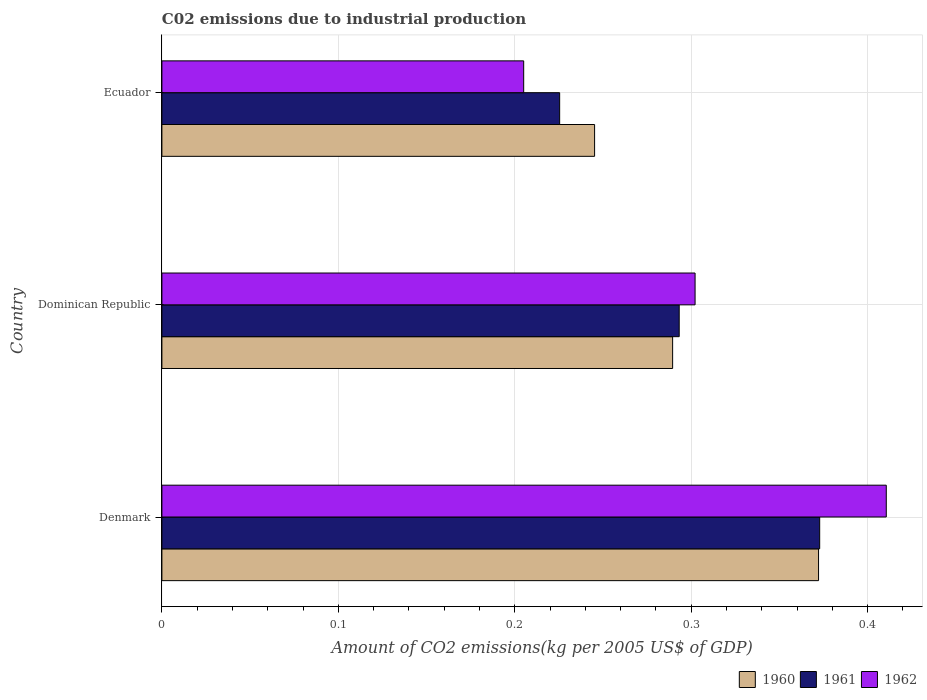How many bars are there on the 2nd tick from the bottom?
Your answer should be compact. 3. What is the label of the 1st group of bars from the top?
Keep it short and to the point. Ecuador. What is the amount of CO2 emitted due to industrial production in 1962 in Dominican Republic?
Make the answer very short. 0.3. Across all countries, what is the maximum amount of CO2 emitted due to industrial production in 1961?
Provide a short and direct response. 0.37. Across all countries, what is the minimum amount of CO2 emitted due to industrial production in 1962?
Provide a succinct answer. 0.21. In which country was the amount of CO2 emitted due to industrial production in 1962 maximum?
Your answer should be compact. Denmark. In which country was the amount of CO2 emitted due to industrial production in 1961 minimum?
Provide a succinct answer. Ecuador. What is the total amount of CO2 emitted due to industrial production in 1961 in the graph?
Keep it short and to the point. 0.89. What is the difference between the amount of CO2 emitted due to industrial production in 1960 in Denmark and that in Dominican Republic?
Your response must be concise. 0.08. What is the difference between the amount of CO2 emitted due to industrial production in 1960 in Ecuador and the amount of CO2 emitted due to industrial production in 1961 in Dominican Republic?
Offer a terse response. -0.05. What is the average amount of CO2 emitted due to industrial production in 1962 per country?
Offer a very short reply. 0.31. What is the difference between the amount of CO2 emitted due to industrial production in 1961 and amount of CO2 emitted due to industrial production in 1960 in Dominican Republic?
Offer a terse response. 0. What is the ratio of the amount of CO2 emitted due to industrial production in 1961 in Denmark to that in Ecuador?
Keep it short and to the point. 1.65. What is the difference between the highest and the second highest amount of CO2 emitted due to industrial production in 1962?
Keep it short and to the point. 0.11. What is the difference between the highest and the lowest amount of CO2 emitted due to industrial production in 1960?
Provide a short and direct response. 0.13. Is the sum of the amount of CO2 emitted due to industrial production in 1960 in Denmark and Dominican Republic greater than the maximum amount of CO2 emitted due to industrial production in 1962 across all countries?
Ensure brevity in your answer.  Yes. What does the 3rd bar from the bottom in Ecuador represents?
Your response must be concise. 1962. What is the difference between two consecutive major ticks on the X-axis?
Give a very brief answer. 0.1. Are the values on the major ticks of X-axis written in scientific E-notation?
Provide a short and direct response. No. Does the graph contain any zero values?
Ensure brevity in your answer.  No. Does the graph contain grids?
Your response must be concise. Yes. Where does the legend appear in the graph?
Your answer should be compact. Bottom right. How are the legend labels stacked?
Offer a terse response. Horizontal. What is the title of the graph?
Make the answer very short. C02 emissions due to industrial production. What is the label or title of the X-axis?
Make the answer very short. Amount of CO2 emissions(kg per 2005 US$ of GDP). What is the label or title of the Y-axis?
Keep it short and to the point. Country. What is the Amount of CO2 emissions(kg per 2005 US$ of GDP) in 1960 in Denmark?
Offer a terse response. 0.37. What is the Amount of CO2 emissions(kg per 2005 US$ of GDP) of 1961 in Denmark?
Ensure brevity in your answer.  0.37. What is the Amount of CO2 emissions(kg per 2005 US$ of GDP) in 1962 in Denmark?
Your answer should be compact. 0.41. What is the Amount of CO2 emissions(kg per 2005 US$ of GDP) in 1960 in Dominican Republic?
Offer a very short reply. 0.29. What is the Amount of CO2 emissions(kg per 2005 US$ of GDP) in 1961 in Dominican Republic?
Offer a terse response. 0.29. What is the Amount of CO2 emissions(kg per 2005 US$ of GDP) of 1962 in Dominican Republic?
Offer a terse response. 0.3. What is the Amount of CO2 emissions(kg per 2005 US$ of GDP) in 1960 in Ecuador?
Offer a terse response. 0.25. What is the Amount of CO2 emissions(kg per 2005 US$ of GDP) of 1961 in Ecuador?
Offer a terse response. 0.23. What is the Amount of CO2 emissions(kg per 2005 US$ of GDP) of 1962 in Ecuador?
Ensure brevity in your answer.  0.21. Across all countries, what is the maximum Amount of CO2 emissions(kg per 2005 US$ of GDP) in 1960?
Give a very brief answer. 0.37. Across all countries, what is the maximum Amount of CO2 emissions(kg per 2005 US$ of GDP) of 1961?
Keep it short and to the point. 0.37. Across all countries, what is the maximum Amount of CO2 emissions(kg per 2005 US$ of GDP) in 1962?
Give a very brief answer. 0.41. Across all countries, what is the minimum Amount of CO2 emissions(kg per 2005 US$ of GDP) of 1960?
Provide a succinct answer. 0.25. Across all countries, what is the minimum Amount of CO2 emissions(kg per 2005 US$ of GDP) of 1961?
Give a very brief answer. 0.23. Across all countries, what is the minimum Amount of CO2 emissions(kg per 2005 US$ of GDP) of 1962?
Your answer should be compact. 0.21. What is the total Amount of CO2 emissions(kg per 2005 US$ of GDP) in 1960 in the graph?
Offer a very short reply. 0.91. What is the total Amount of CO2 emissions(kg per 2005 US$ of GDP) of 1961 in the graph?
Give a very brief answer. 0.89. What is the total Amount of CO2 emissions(kg per 2005 US$ of GDP) in 1962 in the graph?
Your response must be concise. 0.92. What is the difference between the Amount of CO2 emissions(kg per 2005 US$ of GDP) of 1960 in Denmark and that in Dominican Republic?
Offer a terse response. 0.08. What is the difference between the Amount of CO2 emissions(kg per 2005 US$ of GDP) of 1961 in Denmark and that in Dominican Republic?
Offer a very short reply. 0.08. What is the difference between the Amount of CO2 emissions(kg per 2005 US$ of GDP) in 1962 in Denmark and that in Dominican Republic?
Your answer should be very brief. 0.11. What is the difference between the Amount of CO2 emissions(kg per 2005 US$ of GDP) of 1960 in Denmark and that in Ecuador?
Offer a terse response. 0.13. What is the difference between the Amount of CO2 emissions(kg per 2005 US$ of GDP) in 1961 in Denmark and that in Ecuador?
Offer a terse response. 0.15. What is the difference between the Amount of CO2 emissions(kg per 2005 US$ of GDP) of 1962 in Denmark and that in Ecuador?
Provide a succinct answer. 0.21. What is the difference between the Amount of CO2 emissions(kg per 2005 US$ of GDP) of 1960 in Dominican Republic and that in Ecuador?
Provide a short and direct response. 0.04. What is the difference between the Amount of CO2 emissions(kg per 2005 US$ of GDP) in 1961 in Dominican Republic and that in Ecuador?
Your answer should be compact. 0.07. What is the difference between the Amount of CO2 emissions(kg per 2005 US$ of GDP) of 1962 in Dominican Republic and that in Ecuador?
Your response must be concise. 0.1. What is the difference between the Amount of CO2 emissions(kg per 2005 US$ of GDP) of 1960 in Denmark and the Amount of CO2 emissions(kg per 2005 US$ of GDP) of 1961 in Dominican Republic?
Ensure brevity in your answer.  0.08. What is the difference between the Amount of CO2 emissions(kg per 2005 US$ of GDP) of 1960 in Denmark and the Amount of CO2 emissions(kg per 2005 US$ of GDP) of 1962 in Dominican Republic?
Offer a very short reply. 0.07. What is the difference between the Amount of CO2 emissions(kg per 2005 US$ of GDP) of 1961 in Denmark and the Amount of CO2 emissions(kg per 2005 US$ of GDP) of 1962 in Dominican Republic?
Keep it short and to the point. 0.07. What is the difference between the Amount of CO2 emissions(kg per 2005 US$ of GDP) in 1960 in Denmark and the Amount of CO2 emissions(kg per 2005 US$ of GDP) in 1961 in Ecuador?
Your answer should be compact. 0.15. What is the difference between the Amount of CO2 emissions(kg per 2005 US$ of GDP) of 1960 in Denmark and the Amount of CO2 emissions(kg per 2005 US$ of GDP) of 1962 in Ecuador?
Provide a short and direct response. 0.17. What is the difference between the Amount of CO2 emissions(kg per 2005 US$ of GDP) of 1961 in Denmark and the Amount of CO2 emissions(kg per 2005 US$ of GDP) of 1962 in Ecuador?
Provide a short and direct response. 0.17. What is the difference between the Amount of CO2 emissions(kg per 2005 US$ of GDP) in 1960 in Dominican Republic and the Amount of CO2 emissions(kg per 2005 US$ of GDP) in 1961 in Ecuador?
Offer a very short reply. 0.06. What is the difference between the Amount of CO2 emissions(kg per 2005 US$ of GDP) of 1960 in Dominican Republic and the Amount of CO2 emissions(kg per 2005 US$ of GDP) of 1962 in Ecuador?
Make the answer very short. 0.08. What is the difference between the Amount of CO2 emissions(kg per 2005 US$ of GDP) in 1961 in Dominican Republic and the Amount of CO2 emissions(kg per 2005 US$ of GDP) in 1962 in Ecuador?
Make the answer very short. 0.09. What is the average Amount of CO2 emissions(kg per 2005 US$ of GDP) in 1960 per country?
Provide a succinct answer. 0.3. What is the average Amount of CO2 emissions(kg per 2005 US$ of GDP) in 1961 per country?
Your response must be concise. 0.3. What is the average Amount of CO2 emissions(kg per 2005 US$ of GDP) of 1962 per country?
Ensure brevity in your answer.  0.31. What is the difference between the Amount of CO2 emissions(kg per 2005 US$ of GDP) of 1960 and Amount of CO2 emissions(kg per 2005 US$ of GDP) of 1961 in Denmark?
Offer a terse response. -0. What is the difference between the Amount of CO2 emissions(kg per 2005 US$ of GDP) in 1960 and Amount of CO2 emissions(kg per 2005 US$ of GDP) in 1962 in Denmark?
Ensure brevity in your answer.  -0.04. What is the difference between the Amount of CO2 emissions(kg per 2005 US$ of GDP) in 1961 and Amount of CO2 emissions(kg per 2005 US$ of GDP) in 1962 in Denmark?
Your response must be concise. -0.04. What is the difference between the Amount of CO2 emissions(kg per 2005 US$ of GDP) in 1960 and Amount of CO2 emissions(kg per 2005 US$ of GDP) in 1961 in Dominican Republic?
Give a very brief answer. -0. What is the difference between the Amount of CO2 emissions(kg per 2005 US$ of GDP) of 1960 and Amount of CO2 emissions(kg per 2005 US$ of GDP) of 1962 in Dominican Republic?
Ensure brevity in your answer.  -0.01. What is the difference between the Amount of CO2 emissions(kg per 2005 US$ of GDP) in 1961 and Amount of CO2 emissions(kg per 2005 US$ of GDP) in 1962 in Dominican Republic?
Provide a short and direct response. -0.01. What is the difference between the Amount of CO2 emissions(kg per 2005 US$ of GDP) in 1960 and Amount of CO2 emissions(kg per 2005 US$ of GDP) in 1961 in Ecuador?
Make the answer very short. 0.02. What is the difference between the Amount of CO2 emissions(kg per 2005 US$ of GDP) of 1960 and Amount of CO2 emissions(kg per 2005 US$ of GDP) of 1962 in Ecuador?
Your response must be concise. 0.04. What is the difference between the Amount of CO2 emissions(kg per 2005 US$ of GDP) of 1961 and Amount of CO2 emissions(kg per 2005 US$ of GDP) of 1962 in Ecuador?
Make the answer very short. 0.02. What is the ratio of the Amount of CO2 emissions(kg per 2005 US$ of GDP) of 1961 in Denmark to that in Dominican Republic?
Ensure brevity in your answer.  1.27. What is the ratio of the Amount of CO2 emissions(kg per 2005 US$ of GDP) in 1962 in Denmark to that in Dominican Republic?
Give a very brief answer. 1.36. What is the ratio of the Amount of CO2 emissions(kg per 2005 US$ of GDP) of 1960 in Denmark to that in Ecuador?
Ensure brevity in your answer.  1.52. What is the ratio of the Amount of CO2 emissions(kg per 2005 US$ of GDP) in 1961 in Denmark to that in Ecuador?
Offer a terse response. 1.65. What is the ratio of the Amount of CO2 emissions(kg per 2005 US$ of GDP) in 1962 in Denmark to that in Ecuador?
Give a very brief answer. 2. What is the ratio of the Amount of CO2 emissions(kg per 2005 US$ of GDP) of 1960 in Dominican Republic to that in Ecuador?
Provide a short and direct response. 1.18. What is the ratio of the Amount of CO2 emissions(kg per 2005 US$ of GDP) of 1961 in Dominican Republic to that in Ecuador?
Keep it short and to the point. 1.3. What is the ratio of the Amount of CO2 emissions(kg per 2005 US$ of GDP) of 1962 in Dominican Republic to that in Ecuador?
Your answer should be very brief. 1.47. What is the difference between the highest and the second highest Amount of CO2 emissions(kg per 2005 US$ of GDP) of 1960?
Ensure brevity in your answer.  0.08. What is the difference between the highest and the second highest Amount of CO2 emissions(kg per 2005 US$ of GDP) in 1961?
Your answer should be compact. 0.08. What is the difference between the highest and the second highest Amount of CO2 emissions(kg per 2005 US$ of GDP) in 1962?
Provide a succinct answer. 0.11. What is the difference between the highest and the lowest Amount of CO2 emissions(kg per 2005 US$ of GDP) in 1960?
Make the answer very short. 0.13. What is the difference between the highest and the lowest Amount of CO2 emissions(kg per 2005 US$ of GDP) in 1961?
Your answer should be very brief. 0.15. What is the difference between the highest and the lowest Amount of CO2 emissions(kg per 2005 US$ of GDP) in 1962?
Offer a terse response. 0.21. 